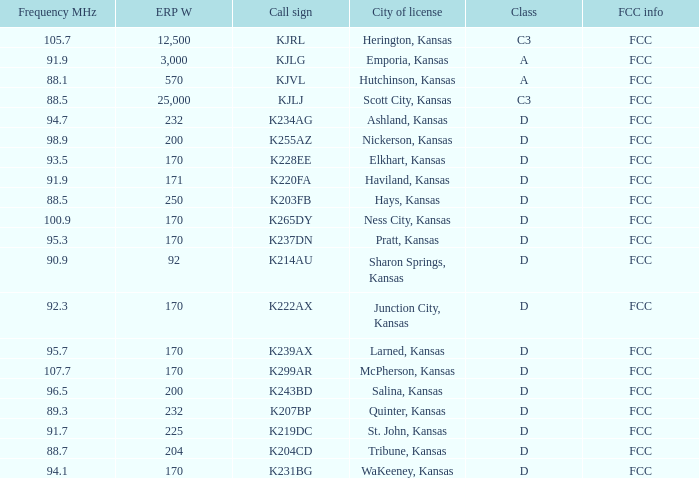Frequency MHz of 88.7 had what average erp w? 204.0. 